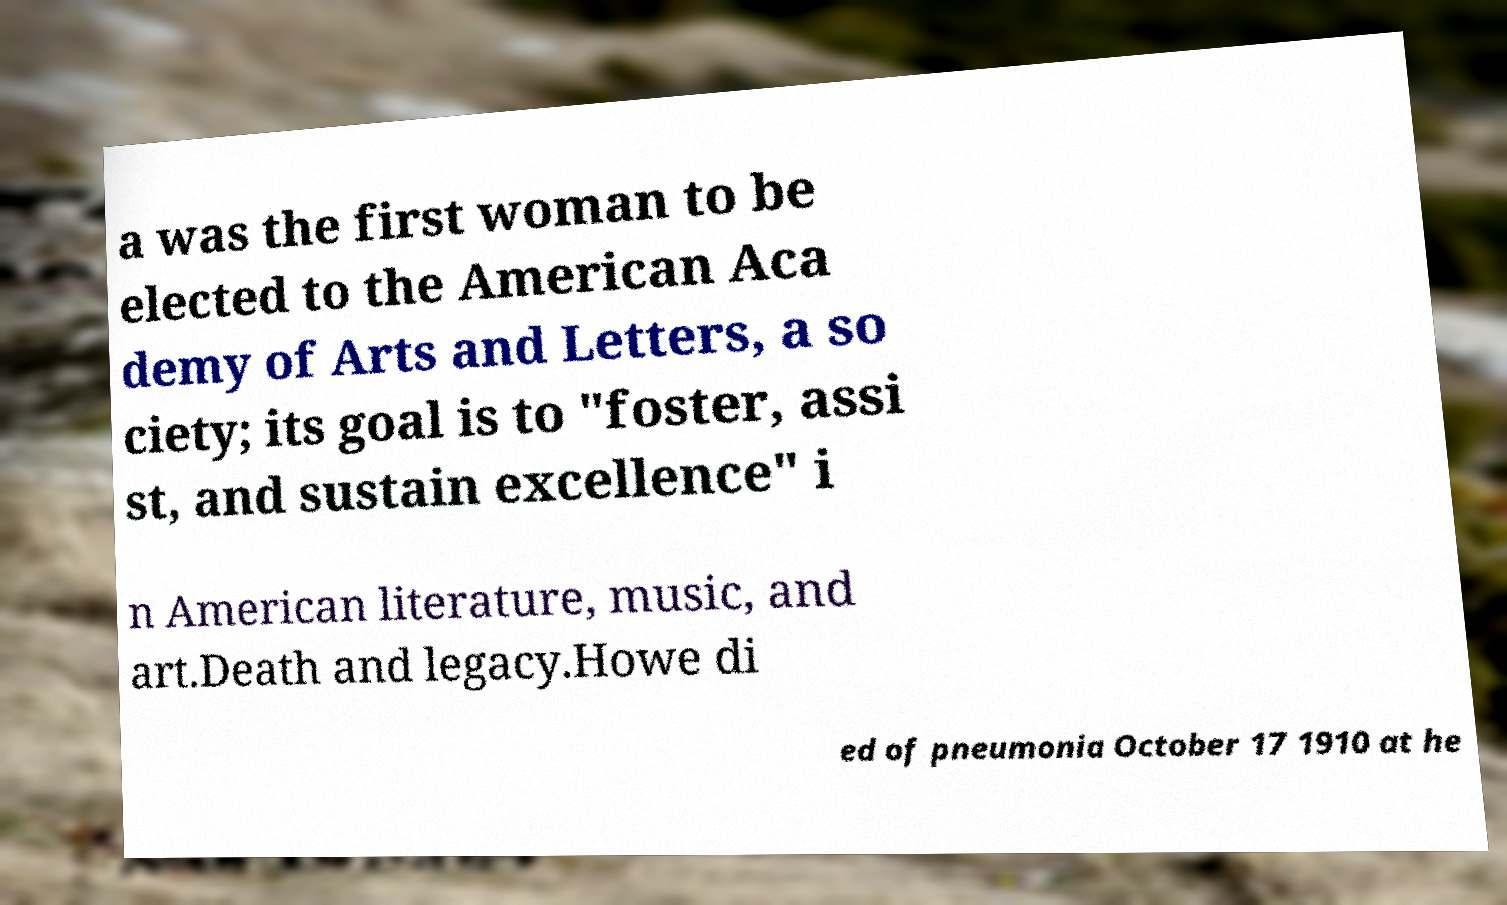Please identify and transcribe the text found in this image. a was the first woman to be elected to the American Aca demy of Arts and Letters, a so ciety; its goal is to "foster, assi st, and sustain excellence" i n American literature, music, and art.Death and legacy.Howe di ed of pneumonia October 17 1910 at he 